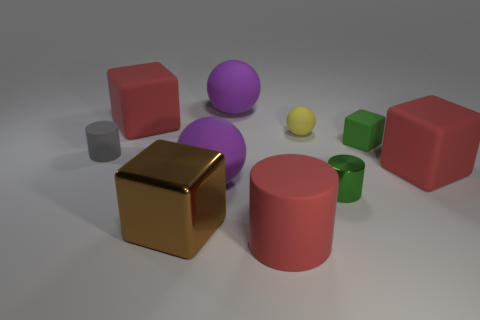What is the material of the gray cylinder that is the same size as the green cylinder?
Your response must be concise. Rubber. Are there any purple shiny things that have the same size as the red rubber cylinder?
Provide a short and direct response. No. There is a red rubber cube left of the large brown metallic object; what is its size?
Offer a very short reply. Large. What size is the metal block?
Provide a short and direct response. Large. What number of spheres are yellow rubber objects or brown objects?
Your answer should be very brief. 1. There is a gray object that is made of the same material as the tiny green block; what is its size?
Offer a very short reply. Small. How many spheres have the same color as the tiny matte block?
Your answer should be compact. 0. There is a large cylinder; are there any green cylinders on the left side of it?
Ensure brevity in your answer.  No. Is the shape of the tiny green matte object the same as the large brown thing left of the metallic cylinder?
Keep it short and to the point. Yes. What number of things are either rubber cylinders on the left side of the brown block or brown shiny cylinders?
Make the answer very short. 1. 